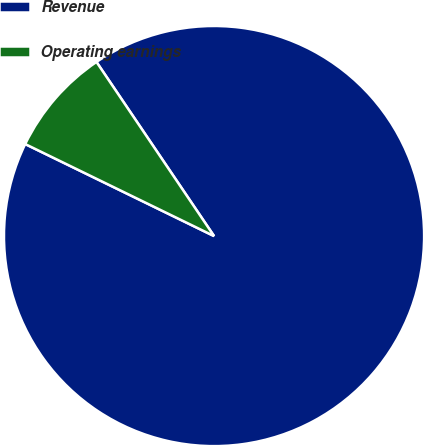Convert chart to OTSL. <chart><loc_0><loc_0><loc_500><loc_500><pie_chart><fcel>Revenue<fcel>Operating earnings<nl><fcel>91.67%<fcel>8.33%<nl></chart> 